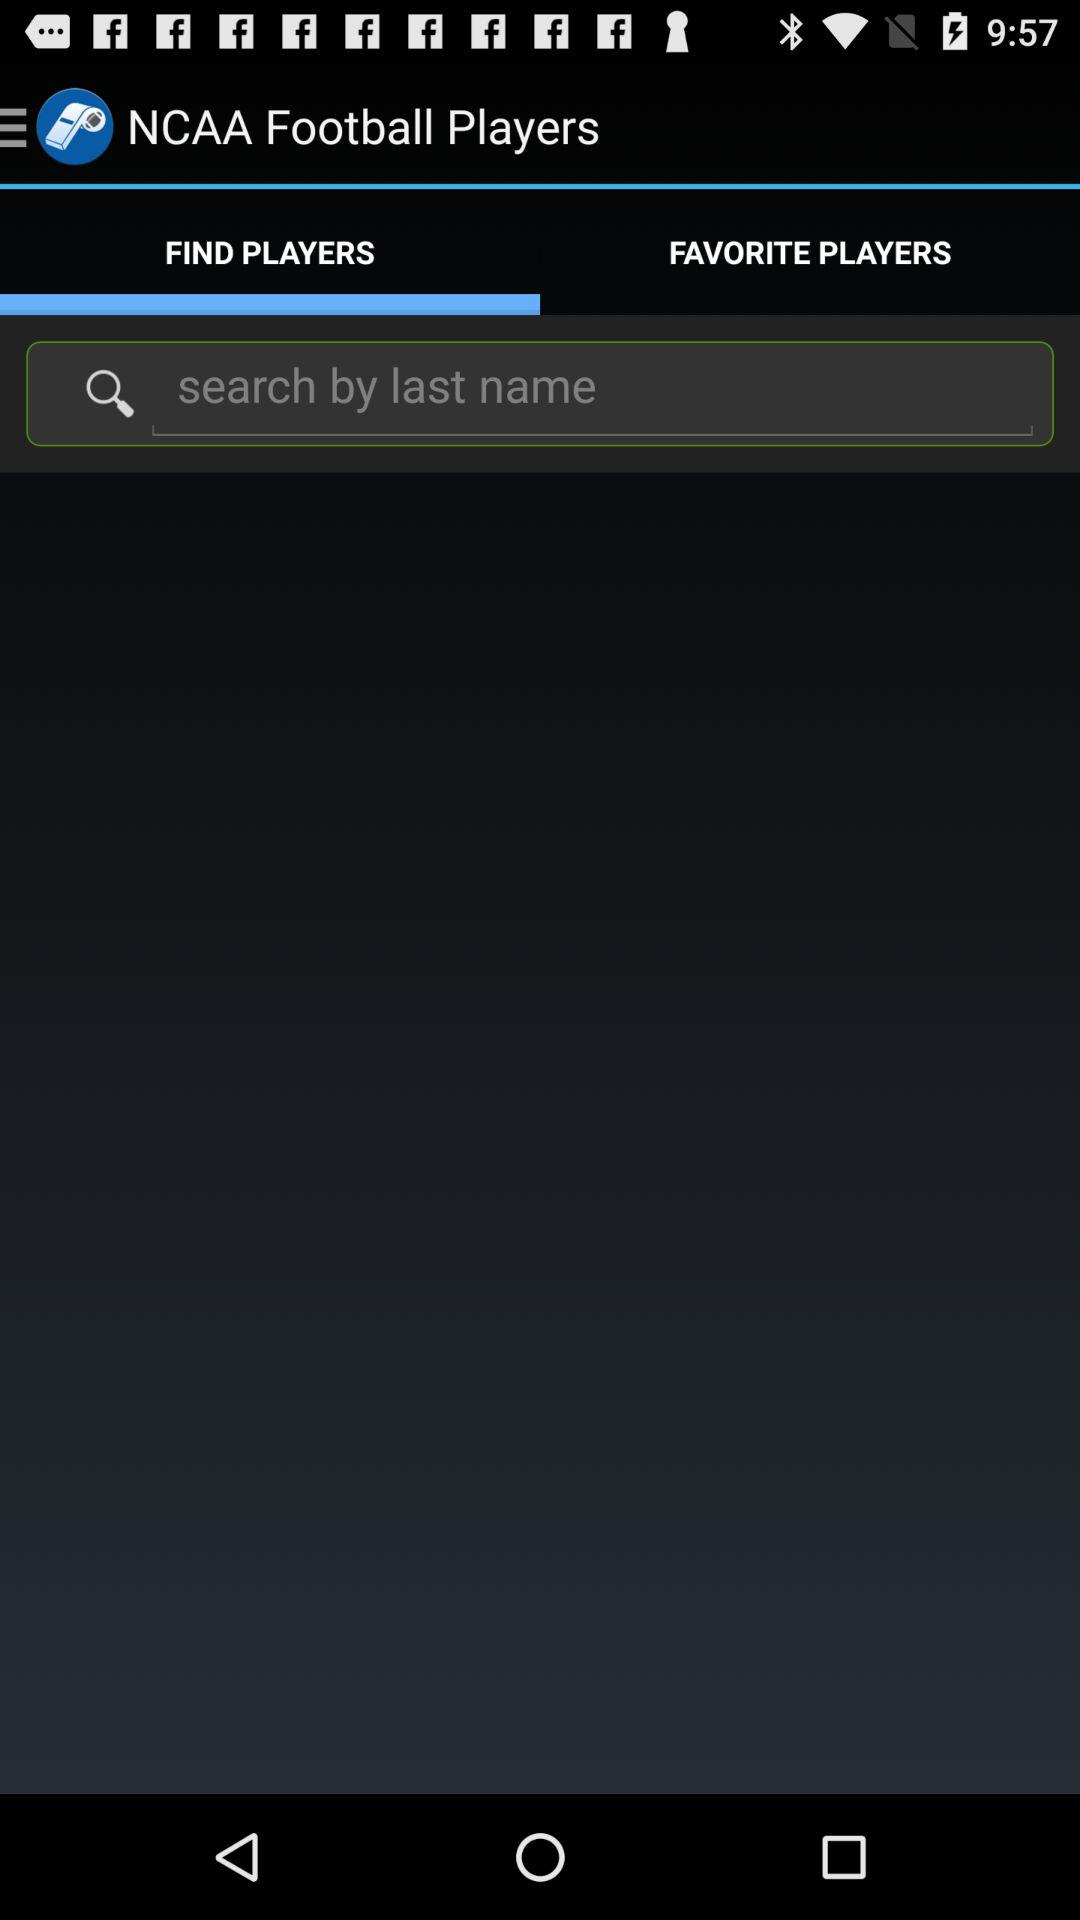What is the application name? The application name is "NCAA Football Players". 